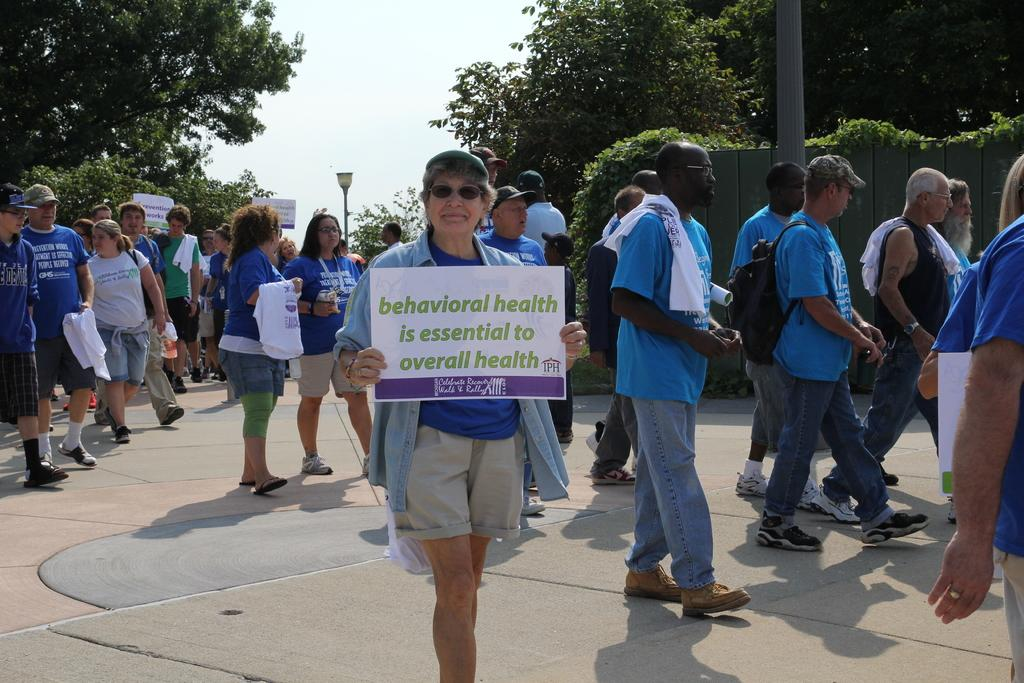How many people are present in the image? There are people in the image, but the exact number is not specified. What is the person holding in the image? The person is holding a board with text written on it. What can be seen in the background of the image? There are trees and the sky visible in the background of the image. What type of sack can be seen hanging from the tree in the image? There is no sack hanging from a tree in the image. How does the grass in the image feel? There is no mention of grass in the image, so it is impossible to determine how it might feel. 